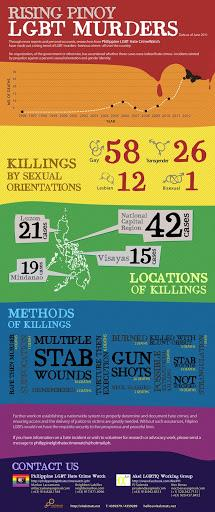Draw attention to some important aspects in this diagram. The most commonly employed method of killing is stabbing, as evidenced by the prevalence of such wounds in forensic cases. 